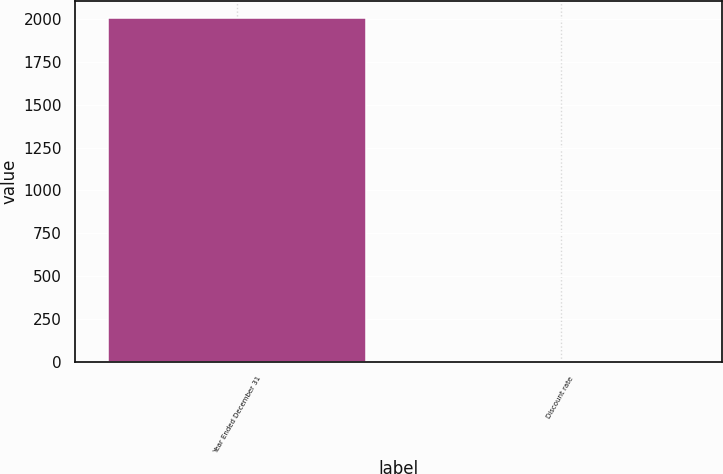<chart> <loc_0><loc_0><loc_500><loc_500><bar_chart><fcel>Year Ended December 31<fcel>Discount rate<nl><fcel>2005<fcel>5.9<nl></chart> 